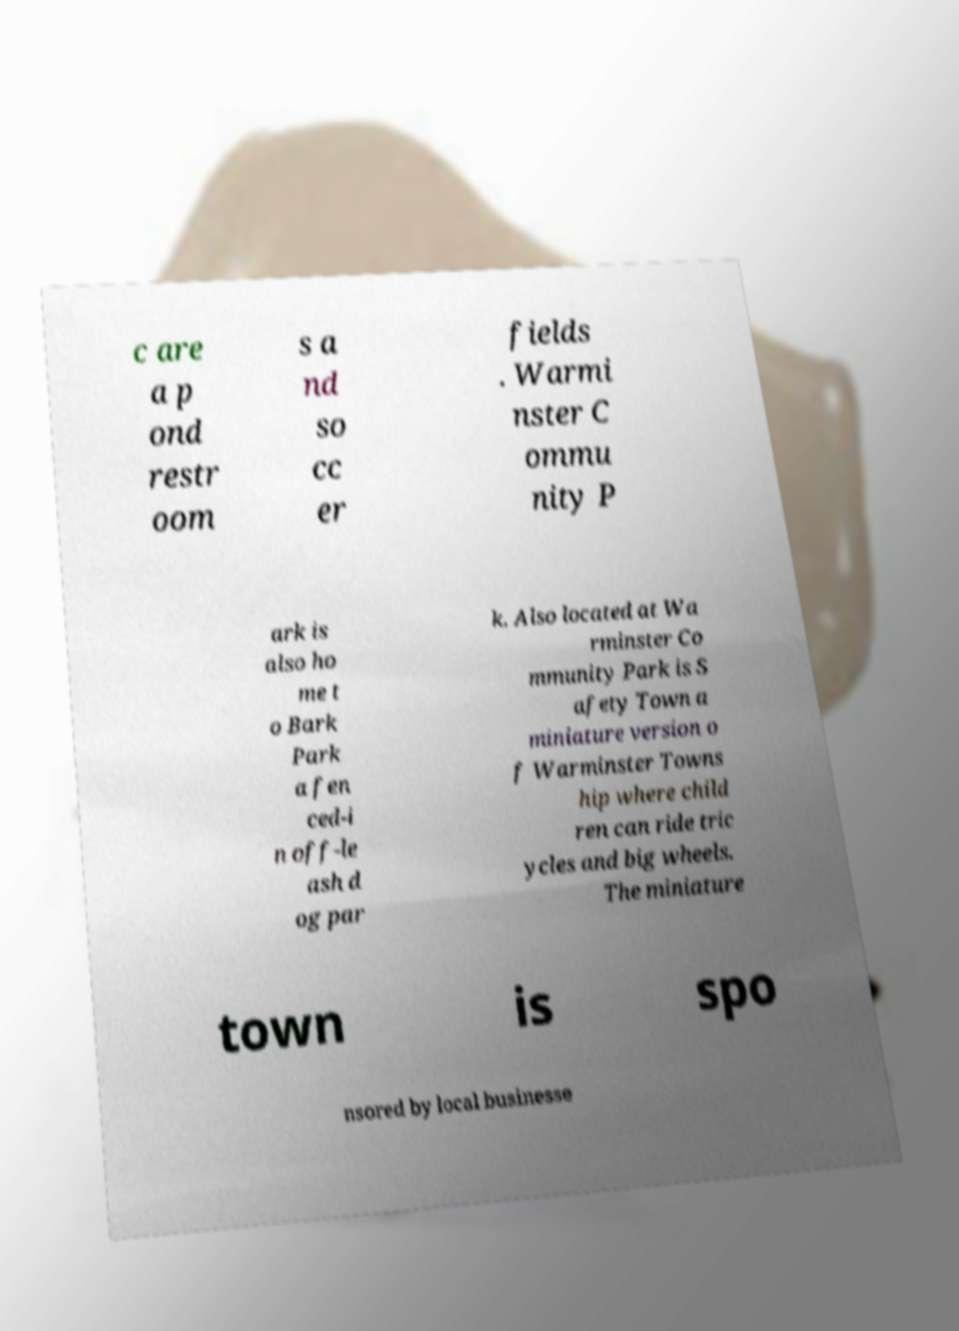I need the written content from this picture converted into text. Can you do that? c are a p ond restr oom s a nd so cc er fields . Warmi nster C ommu nity P ark is also ho me t o Bark Park a fen ced-i n off-le ash d og par k. Also located at Wa rminster Co mmunity Park is S afety Town a miniature version o f Warminster Towns hip where child ren can ride tric ycles and big wheels. The miniature town is spo nsored by local businesse 